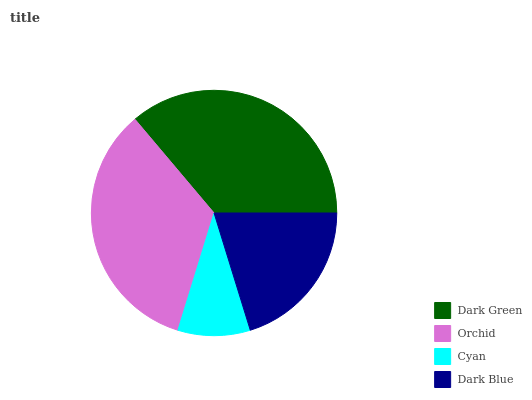Is Cyan the minimum?
Answer yes or no. Yes. Is Dark Green the maximum?
Answer yes or no. Yes. Is Orchid the minimum?
Answer yes or no. No. Is Orchid the maximum?
Answer yes or no. No. Is Dark Green greater than Orchid?
Answer yes or no. Yes. Is Orchid less than Dark Green?
Answer yes or no. Yes. Is Orchid greater than Dark Green?
Answer yes or no. No. Is Dark Green less than Orchid?
Answer yes or no. No. Is Orchid the high median?
Answer yes or no. Yes. Is Dark Blue the low median?
Answer yes or no. Yes. Is Dark Blue the high median?
Answer yes or no. No. Is Orchid the low median?
Answer yes or no. No. 